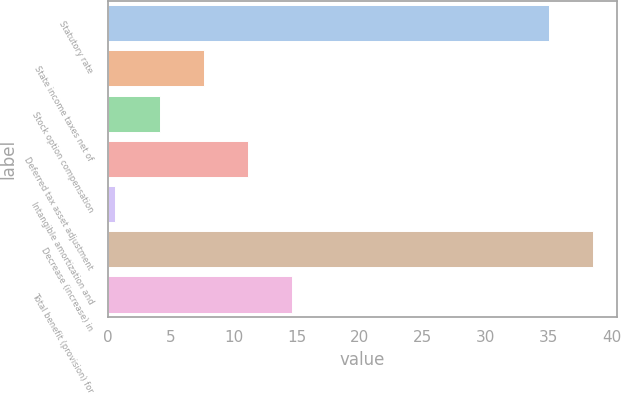Convert chart. <chart><loc_0><loc_0><loc_500><loc_500><bar_chart><fcel>Statutory rate<fcel>State income taxes net of<fcel>Stock option compensation<fcel>Deferred tax asset adjustment<fcel>Intangible amortization and<fcel>Decrease (increase) in<fcel>Total benefit (provision) for<nl><fcel>35<fcel>7.62<fcel>4.11<fcel>11.13<fcel>0.6<fcel>38.51<fcel>14.64<nl></chart> 